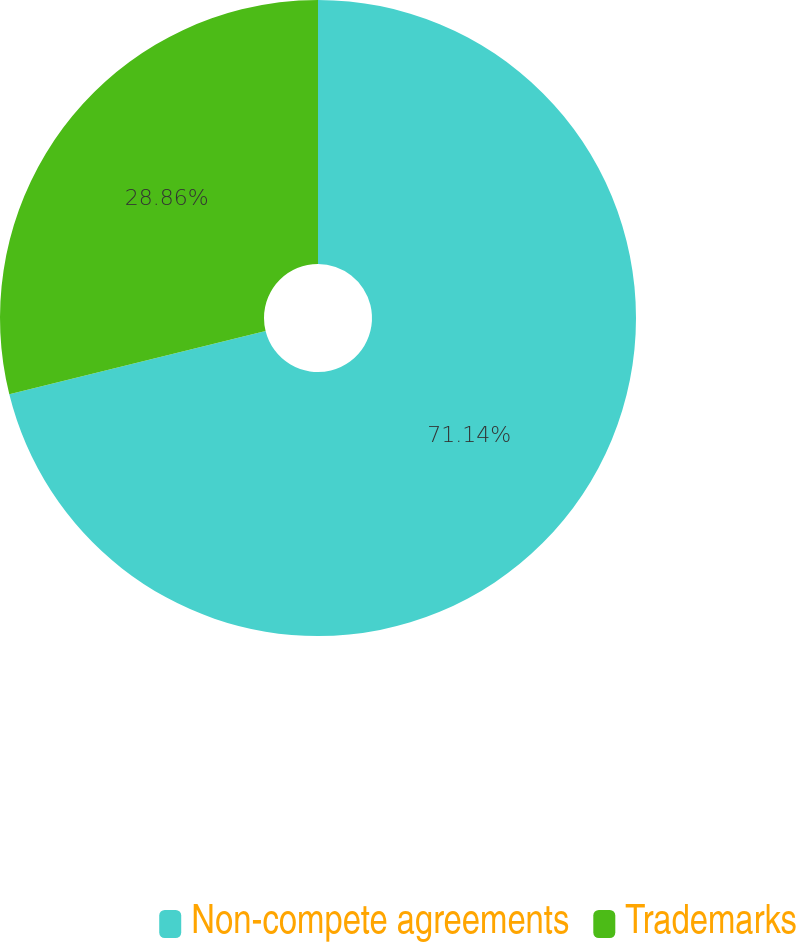Convert chart to OTSL. <chart><loc_0><loc_0><loc_500><loc_500><pie_chart><fcel>Non-compete agreements<fcel>Trademarks<nl><fcel>71.14%<fcel>28.86%<nl></chart> 